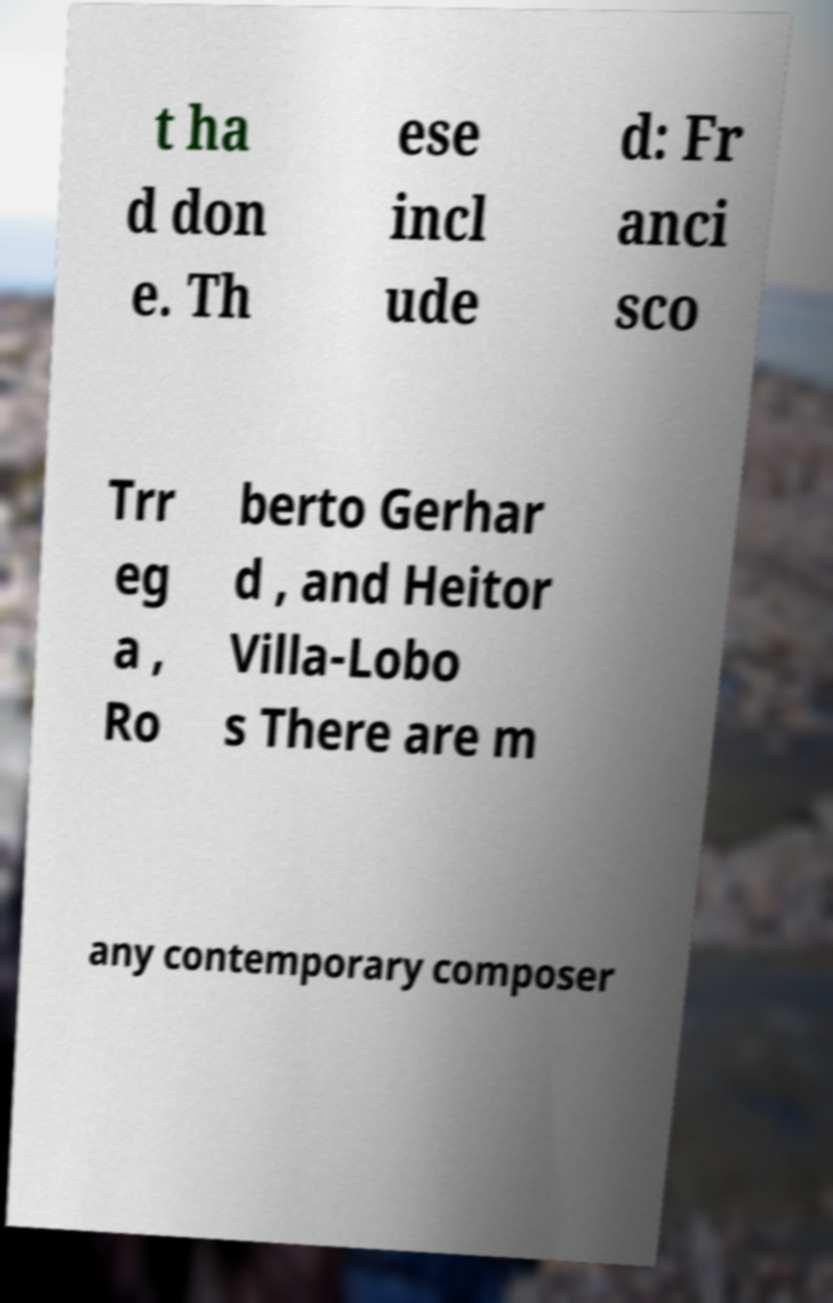I need the written content from this picture converted into text. Can you do that? t ha d don e. Th ese incl ude d: Fr anci sco Trr eg a , Ro berto Gerhar d , and Heitor Villa-Lobo s There are m any contemporary composer 